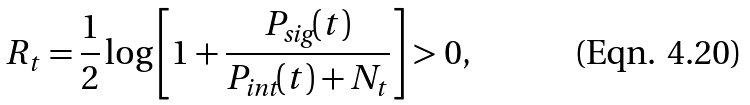Convert formula to latex. <formula><loc_0><loc_0><loc_500><loc_500>R _ { t } = \frac { 1 } { 2 } \log \left [ 1 + \frac { P _ { \text {sig} } ( t ) } { P _ { \text {int} } ( t ) + N _ { t } } \right ] > 0 ,</formula> 